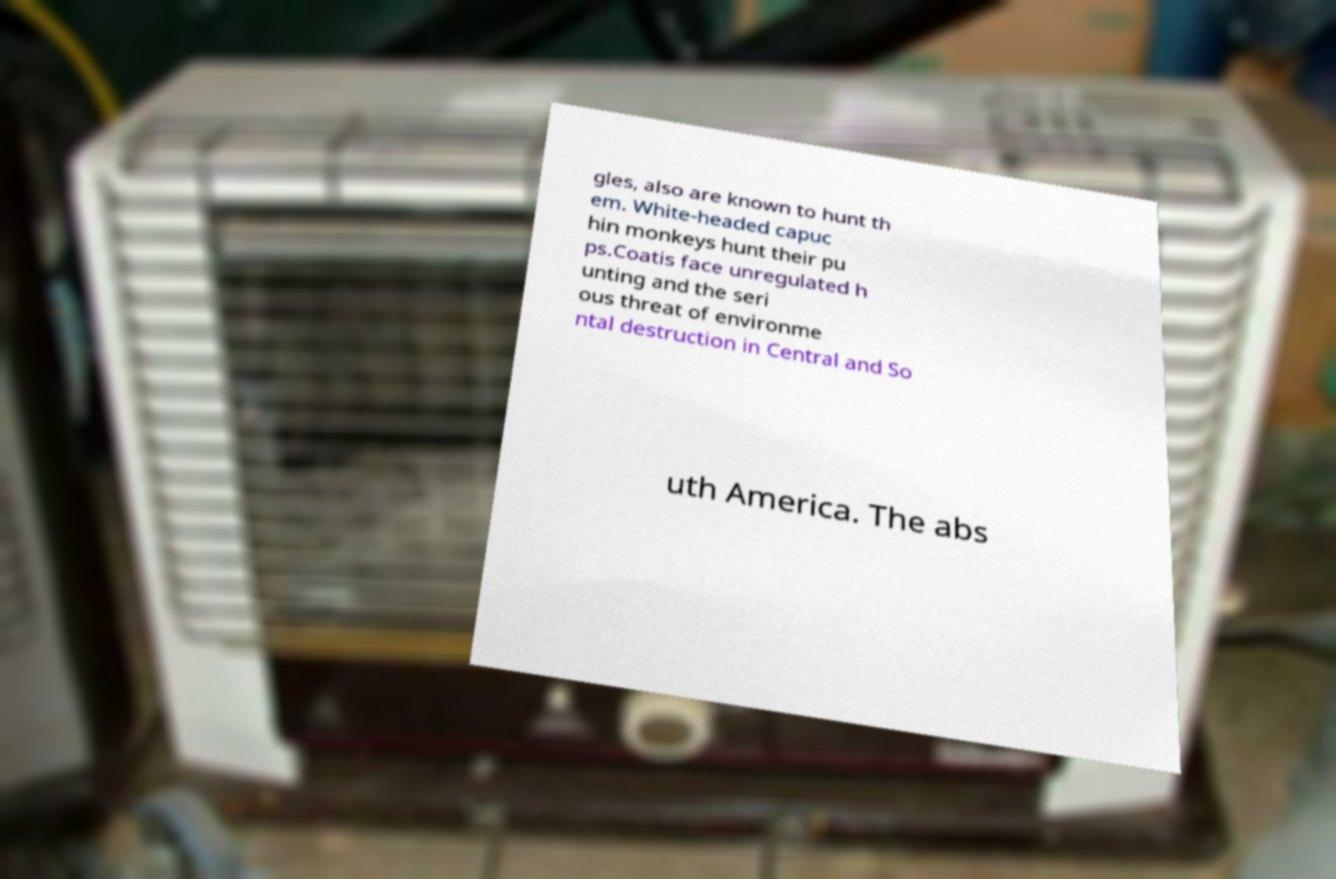For documentation purposes, I need the text within this image transcribed. Could you provide that? gles, also are known to hunt th em. White-headed capuc hin monkeys hunt their pu ps.Coatis face unregulated h unting and the seri ous threat of environme ntal destruction in Central and So uth America. The abs 